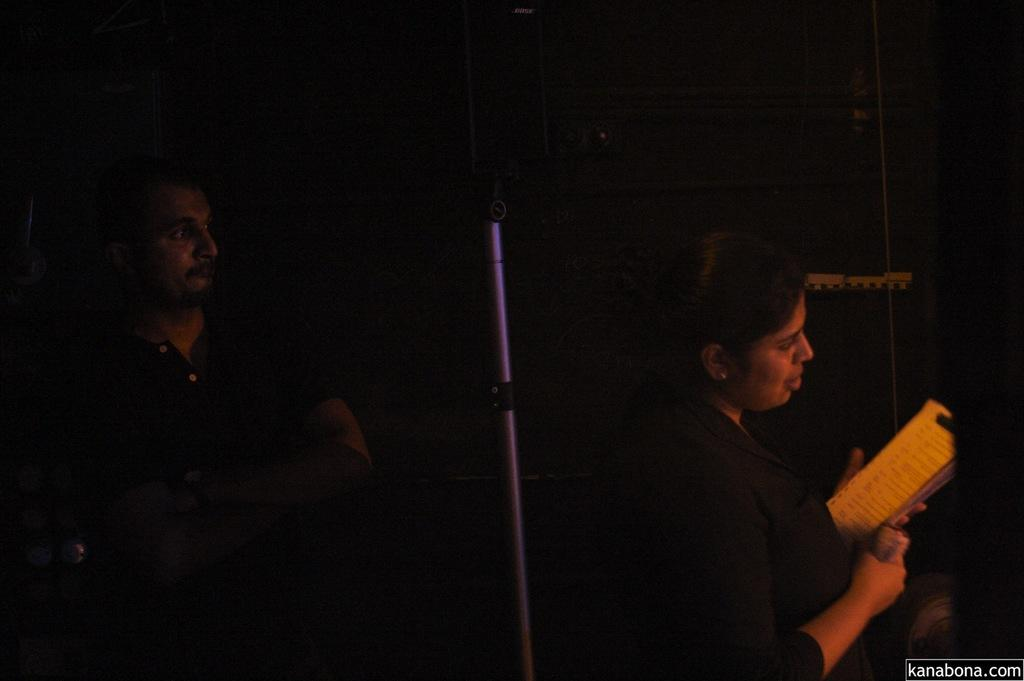How many people are in the image? There is a man and a woman in the image. What is the woman holding in the image? The woman is holding a book. What can be seen in the background of the image? There is a road in the image. Is there any text visible in the image? Yes, there is text in the bottom right corner of the image. Can you hear the man whistling in the image? There is no indication of sound or whistling in the image, as it is a still photograph. What type of clam is being washed by the woman in the image? There is no clam or washing activity present in the image; the woman is holding a book. 